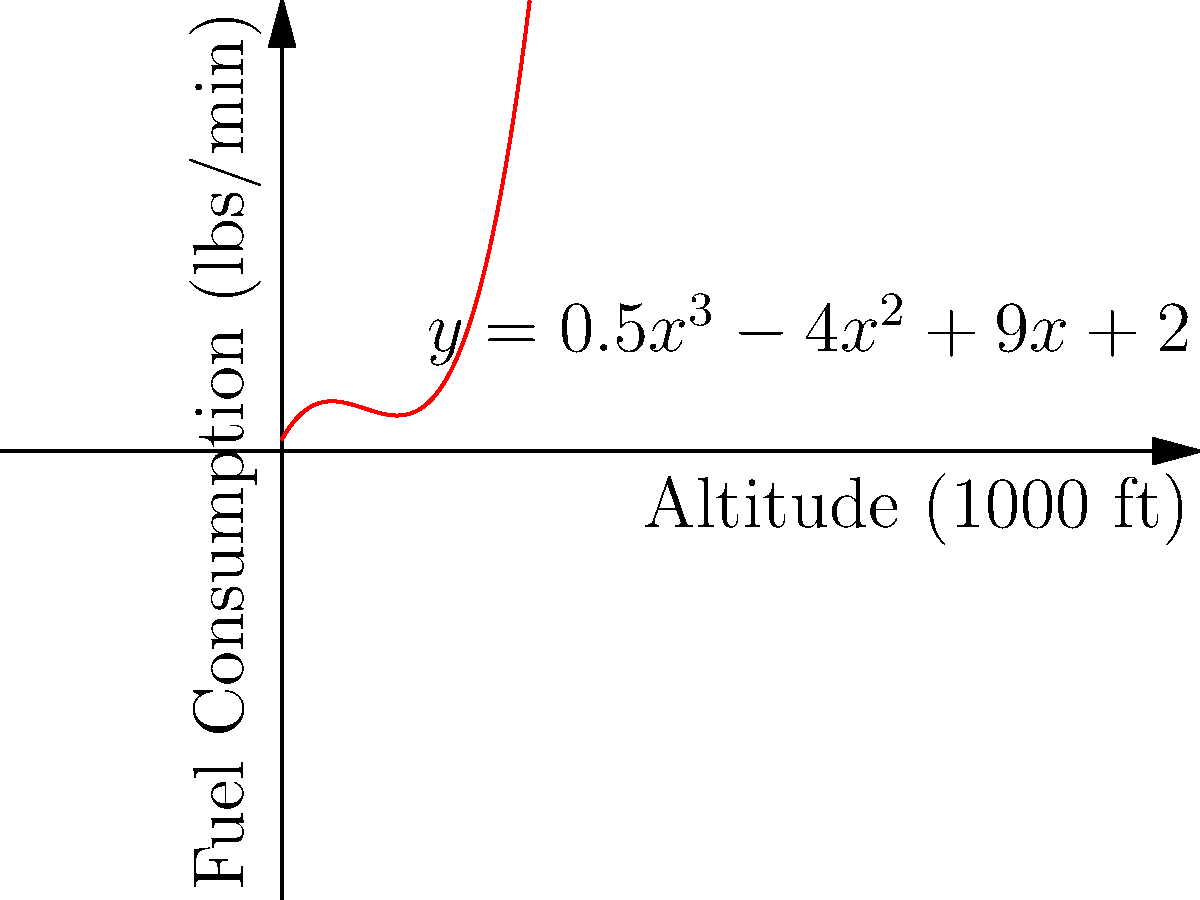As a senior flight captain, you're tasked with optimizing fuel consumption during ascent. The relationship between altitude (x, in thousands of feet) and fuel consumption (y, in pounds per minute) is modeled by the cubic function $y = 0.5x^3 - 4x^2 + 9x + 2$. At what altitude is the fuel consumption rate at its minimum? To find the altitude where fuel consumption is minimized:

1) The minimum point occurs where the derivative of the function is zero. Let's find the derivative:
   $\frac{dy}{dx} = 1.5x^2 - 8x + 9$

2) Set the derivative to zero and solve:
   $1.5x^2 - 8x + 9 = 0$

3) This is a quadratic equation. We can solve it using the quadratic formula:
   $x = \frac{-b \pm \sqrt{b^2 - 4ac}}{2a}$

   Where $a = 1.5$, $b = -8$, and $c = 9$

4) Plugging in these values:
   $x = \frac{8 \pm \sqrt{64 - 54}}{3} = \frac{8 \pm \sqrt{10}}{3}$

5) This gives us two solutions:
   $x_1 = \frac{8 + \sqrt{10}}{3} \approx 4.39$
   $x_2 = \frac{8 - \sqrt{10}}{3} \approx 1.61$

6) To determine which solution gives the minimum, we can check the second derivative:
   $\frac{d^2y}{dx^2} = 3x - 8$

   At $x = 4.39$, this is positive, indicating a minimum.
   At $x = 1.61$, this is negative, indicating a maximum.

Therefore, the fuel consumption is minimized at an altitude of approximately 4.39 thousand feet.
Answer: 4.39 thousand feet 